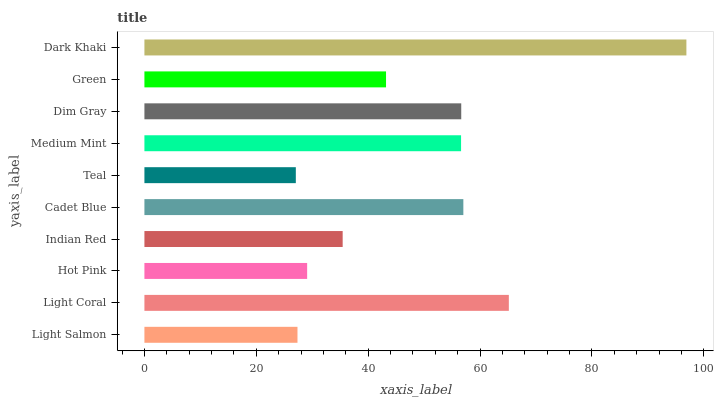Is Teal the minimum?
Answer yes or no. Yes. Is Dark Khaki the maximum?
Answer yes or no. Yes. Is Light Coral the minimum?
Answer yes or no. No. Is Light Coral the maximum?
Answer yes or no. No. Is Light Coral greater than Light Salmon?
Answer yes or no. Yes. Is Light Salmon less than Light Coral?
Answer yes or no. Yes. Is Light Salmon greater than Light Coral?
Answer yes or no. No. Is Light Coral less than Light Salmon?
Answer yes or no. No. Is Medium Mint the high median?
Answer yes or no. Yes. Is Green the low median?
Answer yes or no. Yes. Is Green the high median?
Answer yes or no. No. Is Indian Red the low median?
Answer yes or no. No. 